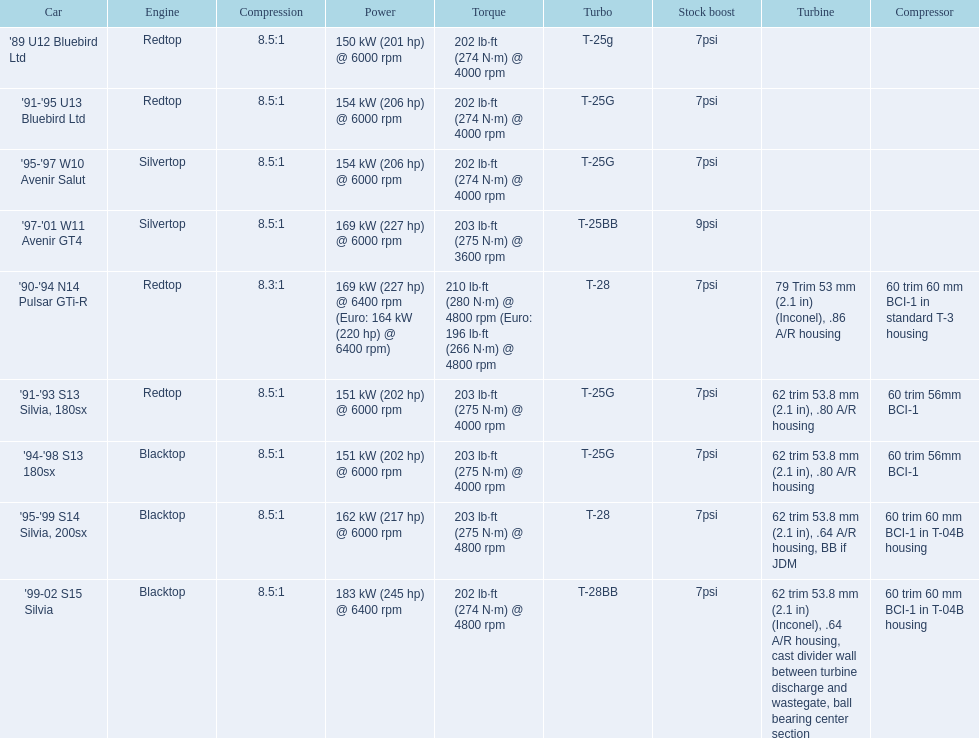Which of the cars uses the redtop engine? '89 U12 Bluebird Ltd, '91-'95 U13 Bluebird Ltd, '90-'94 N14 Pulsar GTi-R, '91-'93 S13 Silvia, 180sx. Of these, has more than 220 horsepower? '90-'94 N14 Pulsar GTi-R. What is the compression ratio of this car? 8.3:1. 